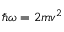Convert formula to latex. <formula><loc_0><loc_0><loc_500><loc_500>\hbar { \omega } = 2 m v ^ { 2 }</formula> 